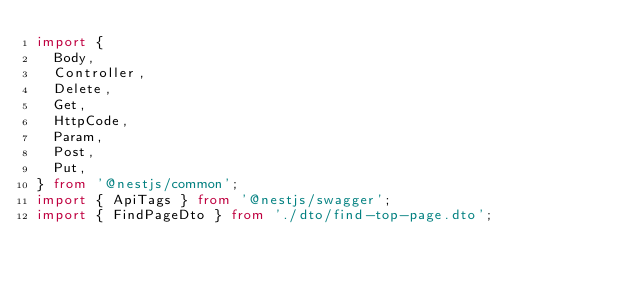<code> <loc_0><loc_0><loc_500><loc_500><_TypeScript_>import {
  Body,
  Controller,
  Delete,
  Get,
  HttpCode,
  Param,
  Post,
  Put,
} from '@nestjs/common';
import { ApiTags } from '@nestjs/swagger';
import { FindPageDto } from './dto/find-top-page.dto';</code> 